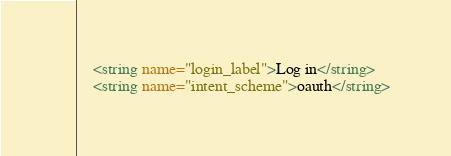<code> <loc_0><loc_0><loc_500><loc_500><_XML_>    <string name="login_label">Log in</string>
    <string name="intent_scheme">oauth</string></code> 